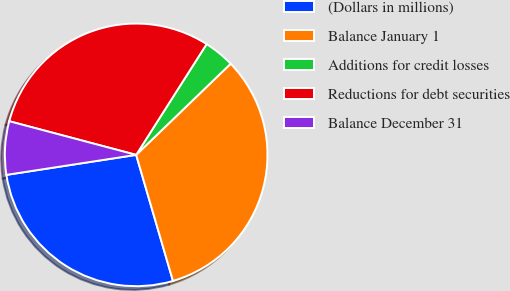<chart> <loc_0><loc_0><loc_500><loc_500><pie_chart><fcel>(Dollars in millions)<fcel>Balance January 1<fcel>Additions for credit losses<fcel>Reductions for debt securities<fcel>Balance December 31<nl><fcel>27.09%<fcel>32.69%<fcel>3.77%<fcel>29.89%<fcel>6.56%<nl></chart> 